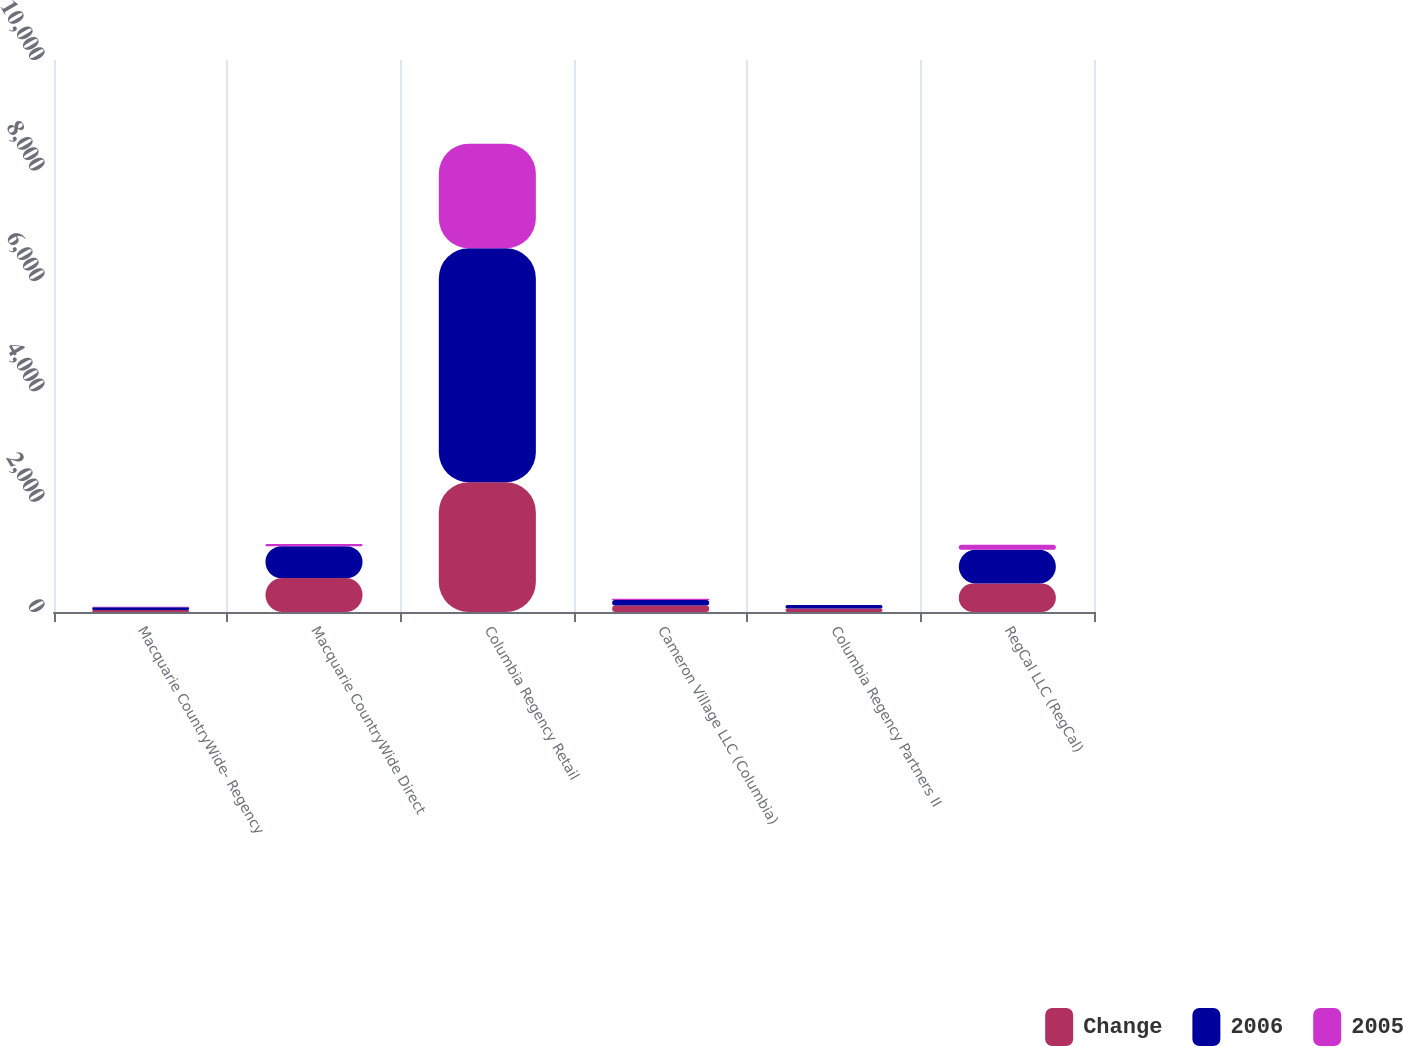<chart> <loc_0><loc_0><loc_500><loc_500><stacked_bar_chart><ecel><fcel>Macquarie CountryWide- Regency<fcel>Macquarie CountryWide Direct<fcel>Columbia Regency Retail<fcel>Cameron Village LLC (Columbia)<fcel>Columbia Regency Partners II<fcel>RegCal LLC (RegCal)<nl><fcel>Change<fcel>38<fcel>615<fcel>2350<fcel>119<fcel>62<fcel>517<nl><fcel>2006<fcel>47<fcel>578<fcel>4241<fcel>98<fcel>63<fcel>609<nl><fcel>2005<fcel>9<fcel>37<fcel>1891<fcel>21<fcel>1<fcel>92<nl></chart> 